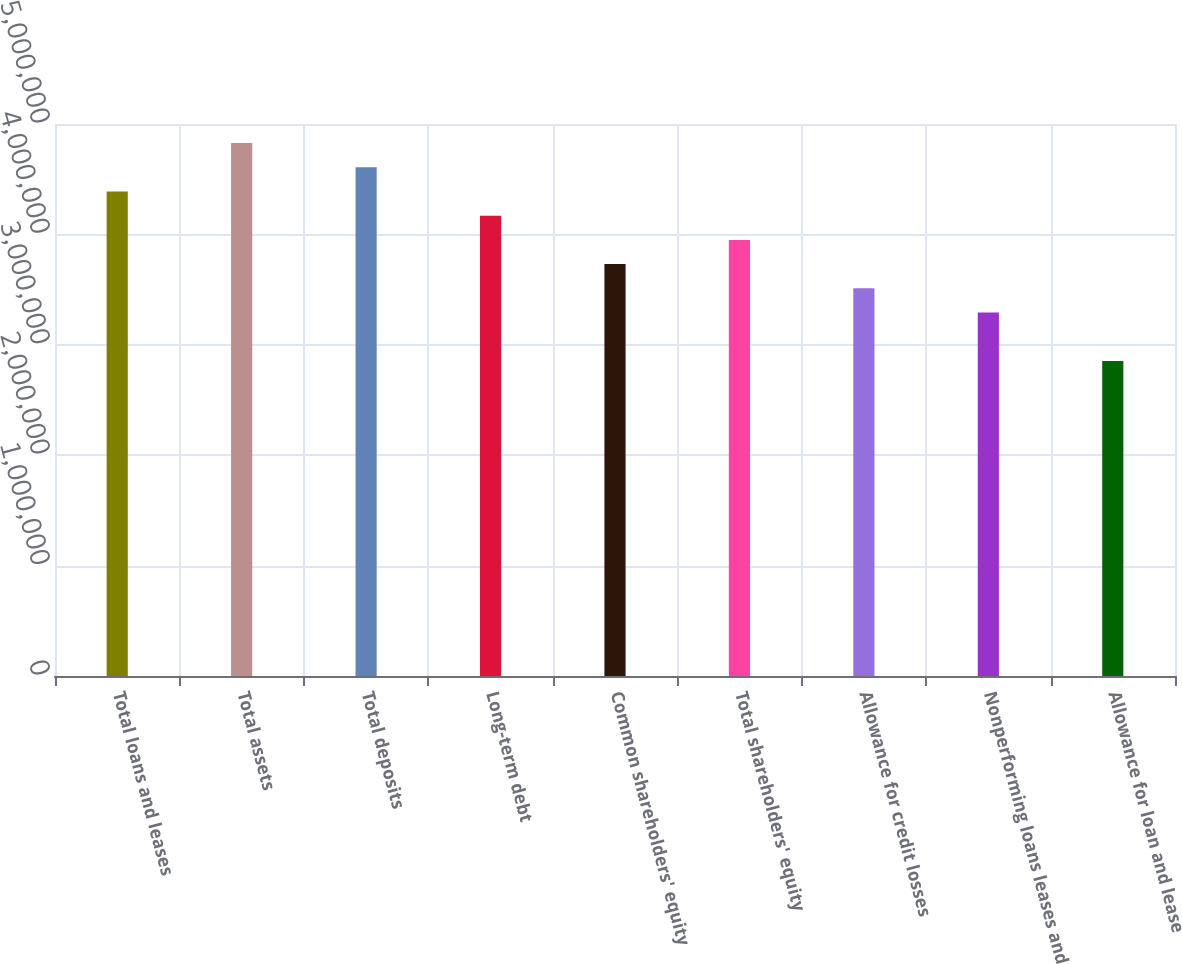Convert chart to OTSL. <chart><loc_0><loc_0><loc_500><loc_500><bar_chart><fcel>Total loans and leases<fcel>Total assets<fcel>Total deposits<fcel>Long-term debt<fcel>Common shareholders' equity<fcel>Total shareholders' equity<fcel>Allowance for credit losses<fcel>Nonperforming loans leases and<fcel>Allowance for loan and lease<nl><fcel>4.38912e+06<fcel>4.82804e+06<fcel>4.60858e+06<fcel>4.16967e+06<fcel>3.73076e+06<fcel>3.95021e+06<fcel>3.5113e+06<fcel>3.29184e+06<fcel>2.85293e+06<nl></chart> 